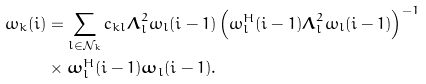<formula> <loc_0><loc_0><loc_500><loc_500>\omega _ { k } ( i ) & = \sum _ { l \in \mathcal { N } _ { k } } c _ { k l } \boldsymbol \Lambda _ { l } ^ { 2 } \omega _ { l } ( i - 1 ) \left ( \omega _ { l } ^ { H } ( i - 1 ) \boldsymbol \Lambda _ { l } ^ { 2 } \omega _ { l } ( i - 1 ) \right ) ^ { - 1 } \\ & \times \boldsymbol \omega _ { l } ^ { H } ( i - 1 ) \boldsymbol \omega _ { l } ( i - 1 ) .</formula> 